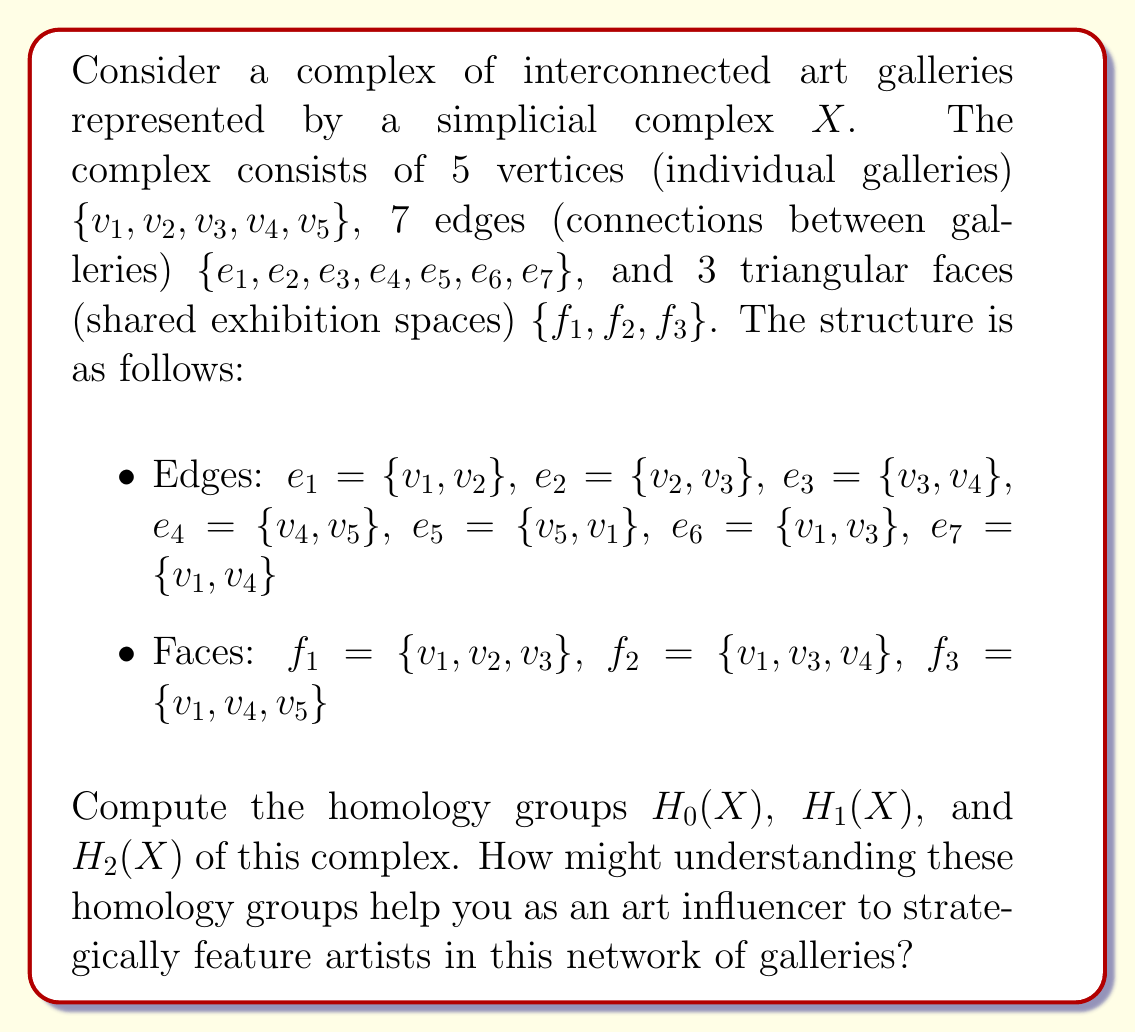Provide a solution to this math problem. To compute the homology groups, we'll follow these steps:

1. Construct the chain complex
2. Calculate the boundary matrices
3. Find the kernel and image of each boundary map
4. Compute the homology groups

Step 1: Chain complex

The chain complex for $X$ is:

$$C_2 \xrightarrow{\partial_2} C_1 \xrightarrow{\partial_1} C_0 \xrightarrow{\partial_0} 0$$

where $C_2$ is generated by the 3 faces, $C_1$ by the 7 edges, and $C_0$ by the 5 vertices.

Step 2: Boundary matrices

$\partial_2$ matrix (3x7):
$$\begin{pmatrix}
-1 & 1 & 0 & 0 & 0 & 1 & 0 \\
0 & -1 & 1 & 0 & 0 & -1 & 1 \\
0 & 0 & -1 & 1 & 1 & 0 & -1
\end{pmatrix}$$

$\partial_1$ matrix (7x5):
$$\begin{pmatrix}
-1 & 1 & 0 & 0 & 0 \\
0 & -1 & 1 & 0 & 0 \\
0 & 0 & -1 & 1 & 0 \\
0 & 0 & 0 & -1 & 1 \\
-1 & 0 & 0 & 0 & 1 \\
-1 & 0 & 1 & 0 & 0 \\
-1 & 0 & 0 & 1 & 0
\end{pmatrix}$$

Step 3: Kernel and image

$\text{ker}(\partial_0) = C_0$ (5-dimensional)
$\text{im}(\partial_1) = \{(a,b,c,d,e) \in C_0 : a+b+c+d+e = 0\}$ (4-dimensional)

$\text{ker}(\partial_1) = \{(a,b,c,d,e,f,g) \in C_1 : a+e+f+g = 0, -a+b-f = 0, -b+c+f-g = 0, -c+d+g = 0\}$ (3-dimensional)
$\text{im}(\partial_2) = \text{ker}(\partial_1)$ (3-dimensional)

$\text{ker}(\partial_2) = \{(0,0,0)\}$ (0-dimensional)

Step 4: Homology groups

$H_0(X) = \text{ker}(\partial_0) / \text{im}(\partial_1) \cong \mathbb{Z}$ (1-dimensional)
$H_1(X) = \text{ker}(\partial_1) / \text{im}(\partial_2) \cong 0$ (0-dimensional)
$H_2(X) = \text{ker}(\partial_2) / \text{im}(\partial_3) \cong 0$ (0-dimensional)

Understanding these homology groups can help an art influencer in the following ways:

1. $H_0(X) \cong \mathbb{Z}$ indicates that the complex is connected, meaning all galleries are accessible from one another. This suggests that featuring an artist in any gallery can potentially reach the entire network.

2. $H_1(X) \cong 0$ implies there are no non-trivial cycles in the complex. This means that any path between two galleries can be continuously deformed into any other path between those galleries. As an influencer, this suggests that there's flexibility in how you navigate the gallery network to feature artists.

3. $H_2(X) \cong 0$ indicates that there are no enclosed voids in the complex. This means that the shared exhibition spaces (triangular faces) don't create any hidden or isolated areas within the network. As an influencer, you can be confident that all exhibition spaces are equally accessible and visible within the network.
Answer: The homology groups of the complex $X$ are:

$H_0(X) \cong \mathbb{Z}$
$H_1(X) \cong 0$
$H_2(X) \cong 0$ 